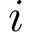Convert formula to latex. <formula><loc_0><loc_0><loc_500><loc_500>i</formula> 